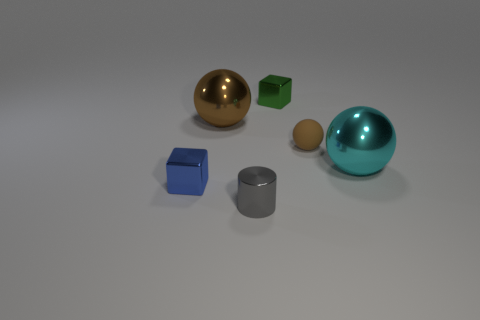What number of tiny things are to the left of the brown matte ball and behind the cyan ball?
Offer a very short reply. 1. Are there the same number of small green metallic things to the left of the tiny green cube and small brown rubber spheres on the right side of the small brown ball?
Ensure brevity in your answer.  Yes. Do the metal thing right of the green metallic object and the small gray thing have the same shape?
Your answer should be very brief. No. There is a large thing behind the big metallic ball that is to the right of the brown thing to the right of the gray metal cylinder; what shape is it?
Your answer should be very brief. Sphere. What shape is the large thing that is the same color as the tiny ball?
Ensure brevity in your answer.  Sphere. There is a thing that is behind the tiny rubber object and to the left of the green shiny block; what material is it?
Keep it short and to the point. Metal. Is the number of large brown objects less than the number of small yellow rubber cylinders?
Your response must be concise. No. There is a small matte thing; is it the same shape as the tiny thing that is behind the tiny rubber ball?
Your answer should be compact. No. Do the blue metallic thing that is left of the gray shiny cylinder and the small brown ball have the same size?
Your response must be concise. Yes. What is the shape of the green thing that is the same size as the blue metal object?
Provide a succinct answer. Cube. 